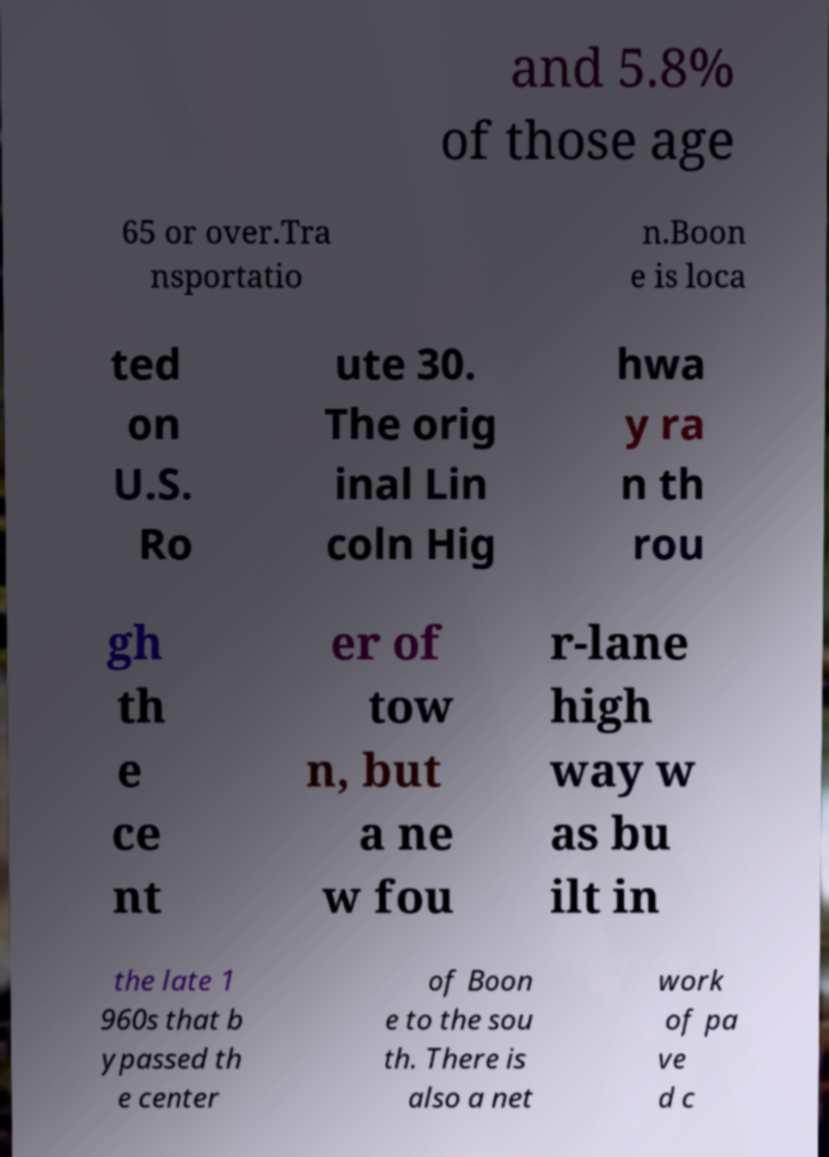Please read and relay the text visible in this image. What does it say? and 5.8% of those age 65 or over.Tra nsportatio n.Boon e is loca ted on U.S. Ro ute 30. The orig inal Lin coln Hig hwa y ra n th rou gh th e ce nt er of tow n, but a ne w fou r-lane high way w as bu ilt in the late 1 960s that b ypassed th e center of Boon e to the sou th. There is also a net work of pa ve d c 